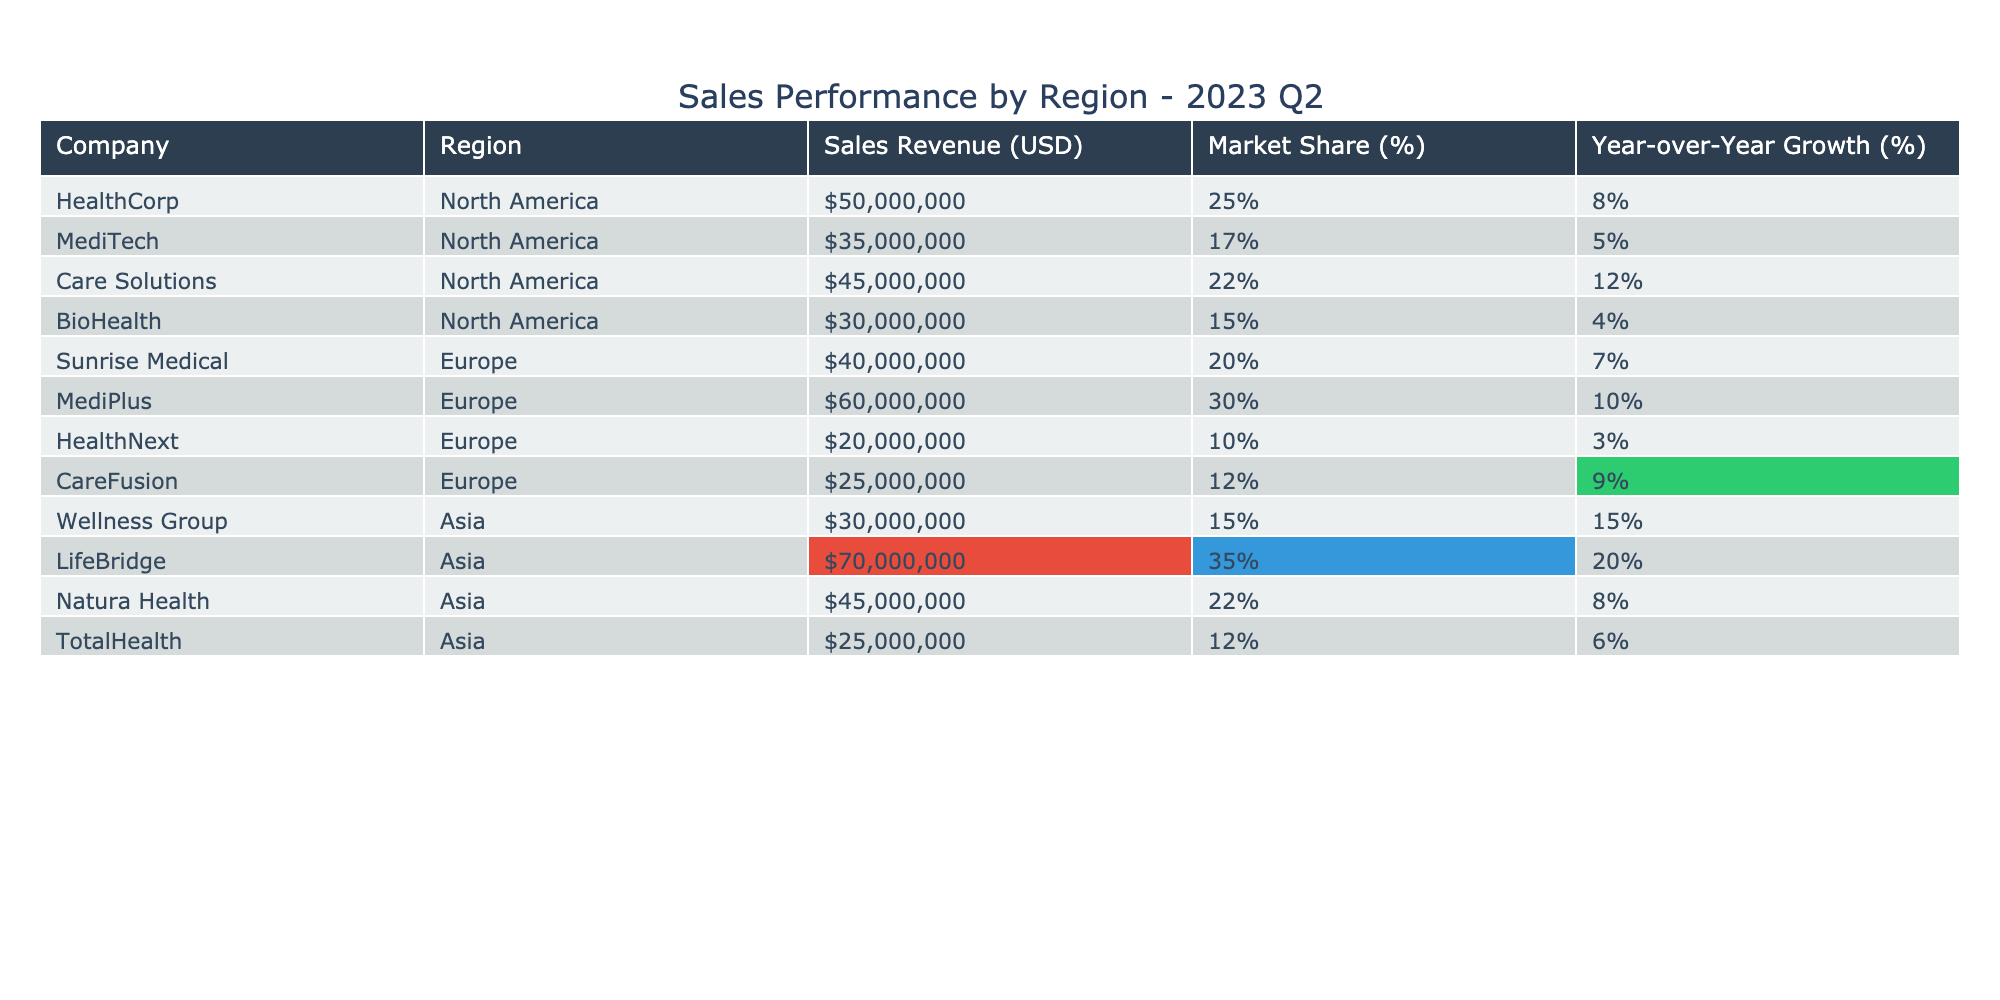What is the highest sales revenue recorded among the companies in the table? By scanning the "Sales Revenue (USD)" column, the highest value is $70,000,000, attributed to LifeBridge.
Answer: $70,000,000 Which company has the largest market share in North America? Looking at the "Market Share (%)" column for the North America region, MediPlus has the highest market share at 30%.
Answer: MediPlus What was the year-over-year growth percentage for Care Solutions? Checking the "Year-over-Year Growth (%)" column for Care Solutions reveals it shows a growth of 12%.
Answer: 12% Which region did HealthCorp operate in? From the "Region" column, HealthCorp is listed under North America.
Answer: North America What is the total sales revenue for all companies in Asia? Adding the sales revenues from the "Sales Revenue (USD)" column for Asia: 30M + 70M + 45M + 25M = 170M.
Answer: $170,000,000 Did any company in Europe have a year-over-year growth above 10%? Reviewing the "Year-over-Year Growth (%)" column for European companies, both MediPlus and CareFusion have growth percentages of 10% and 9%, respectively; therefore, only MediPlus qualifies.
Answer: Yes If we combine the market shares of all companies in North America, what percentage would that total? The North American market shares are: 25% (HealthCorp) + 17% (MediTech) + 22% (Care Solutions) + 15% (BioHealth) = 79%.
Answer: 79% Which Asia company had the lowest sales revenue? By examining the "Sales Revenue (USD)" column under Asia, TotalHealth has the lowest sales revenue at $25,000,000.
Answer: TotalHealth What is the average year-over-year growth for North American companies? Calculate the average growth: (8 + 5 + 12 + 4) / 4 = 29 / 4 = 7.25%.
Answer: 7.25% Which company shows the highest year-over-year growth, and what is that percentage? In the "Year-over-Year Growth (%)" column, LifeBridge has the highest growth at 20%.
Answer: LifeBridge, 20% 